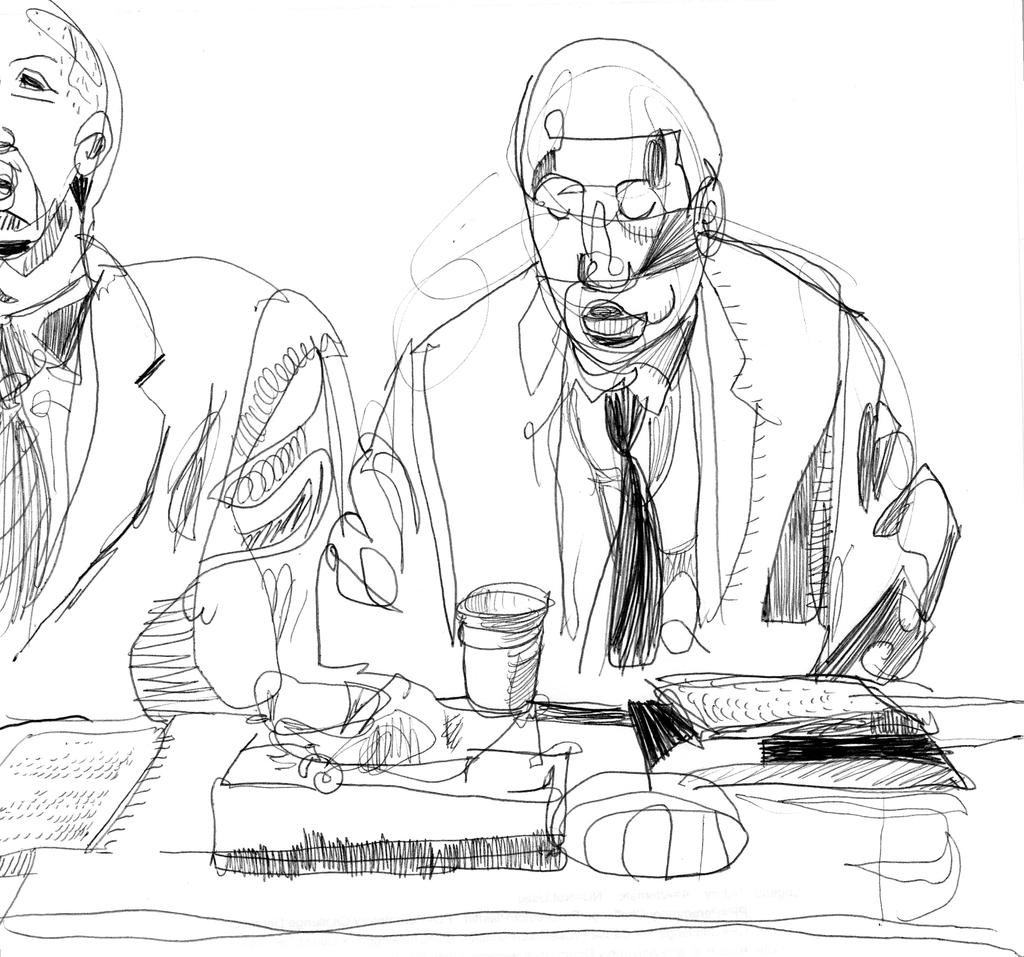What is depicted in the image? There is a sketch of two persons in the image. Can you describe the subjects of the sketch? The sketch features two persons, but their specific characteristics or actions cannot be determined from the provided fact. What type of lunch is being served to the persons in the image? There is no lunch or any indication of food in the image; it only features a sketch of two persons. 